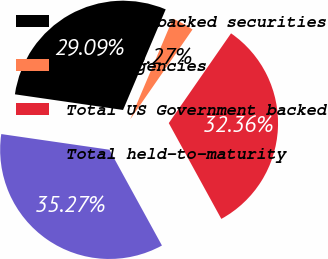Convert chart to OTSL. <chart><loc_0><loc_0><loc_500><loc_500><pie_chart><fcel>Mortgage-backed securities<fcel>Other agencies<fcel>Total US Government backed<fcel>Total held-to-maturity<nl><fcel>29.09%<fcel>3.27%<fcel>32.36%<fcel>35.27%<nl></chart> 